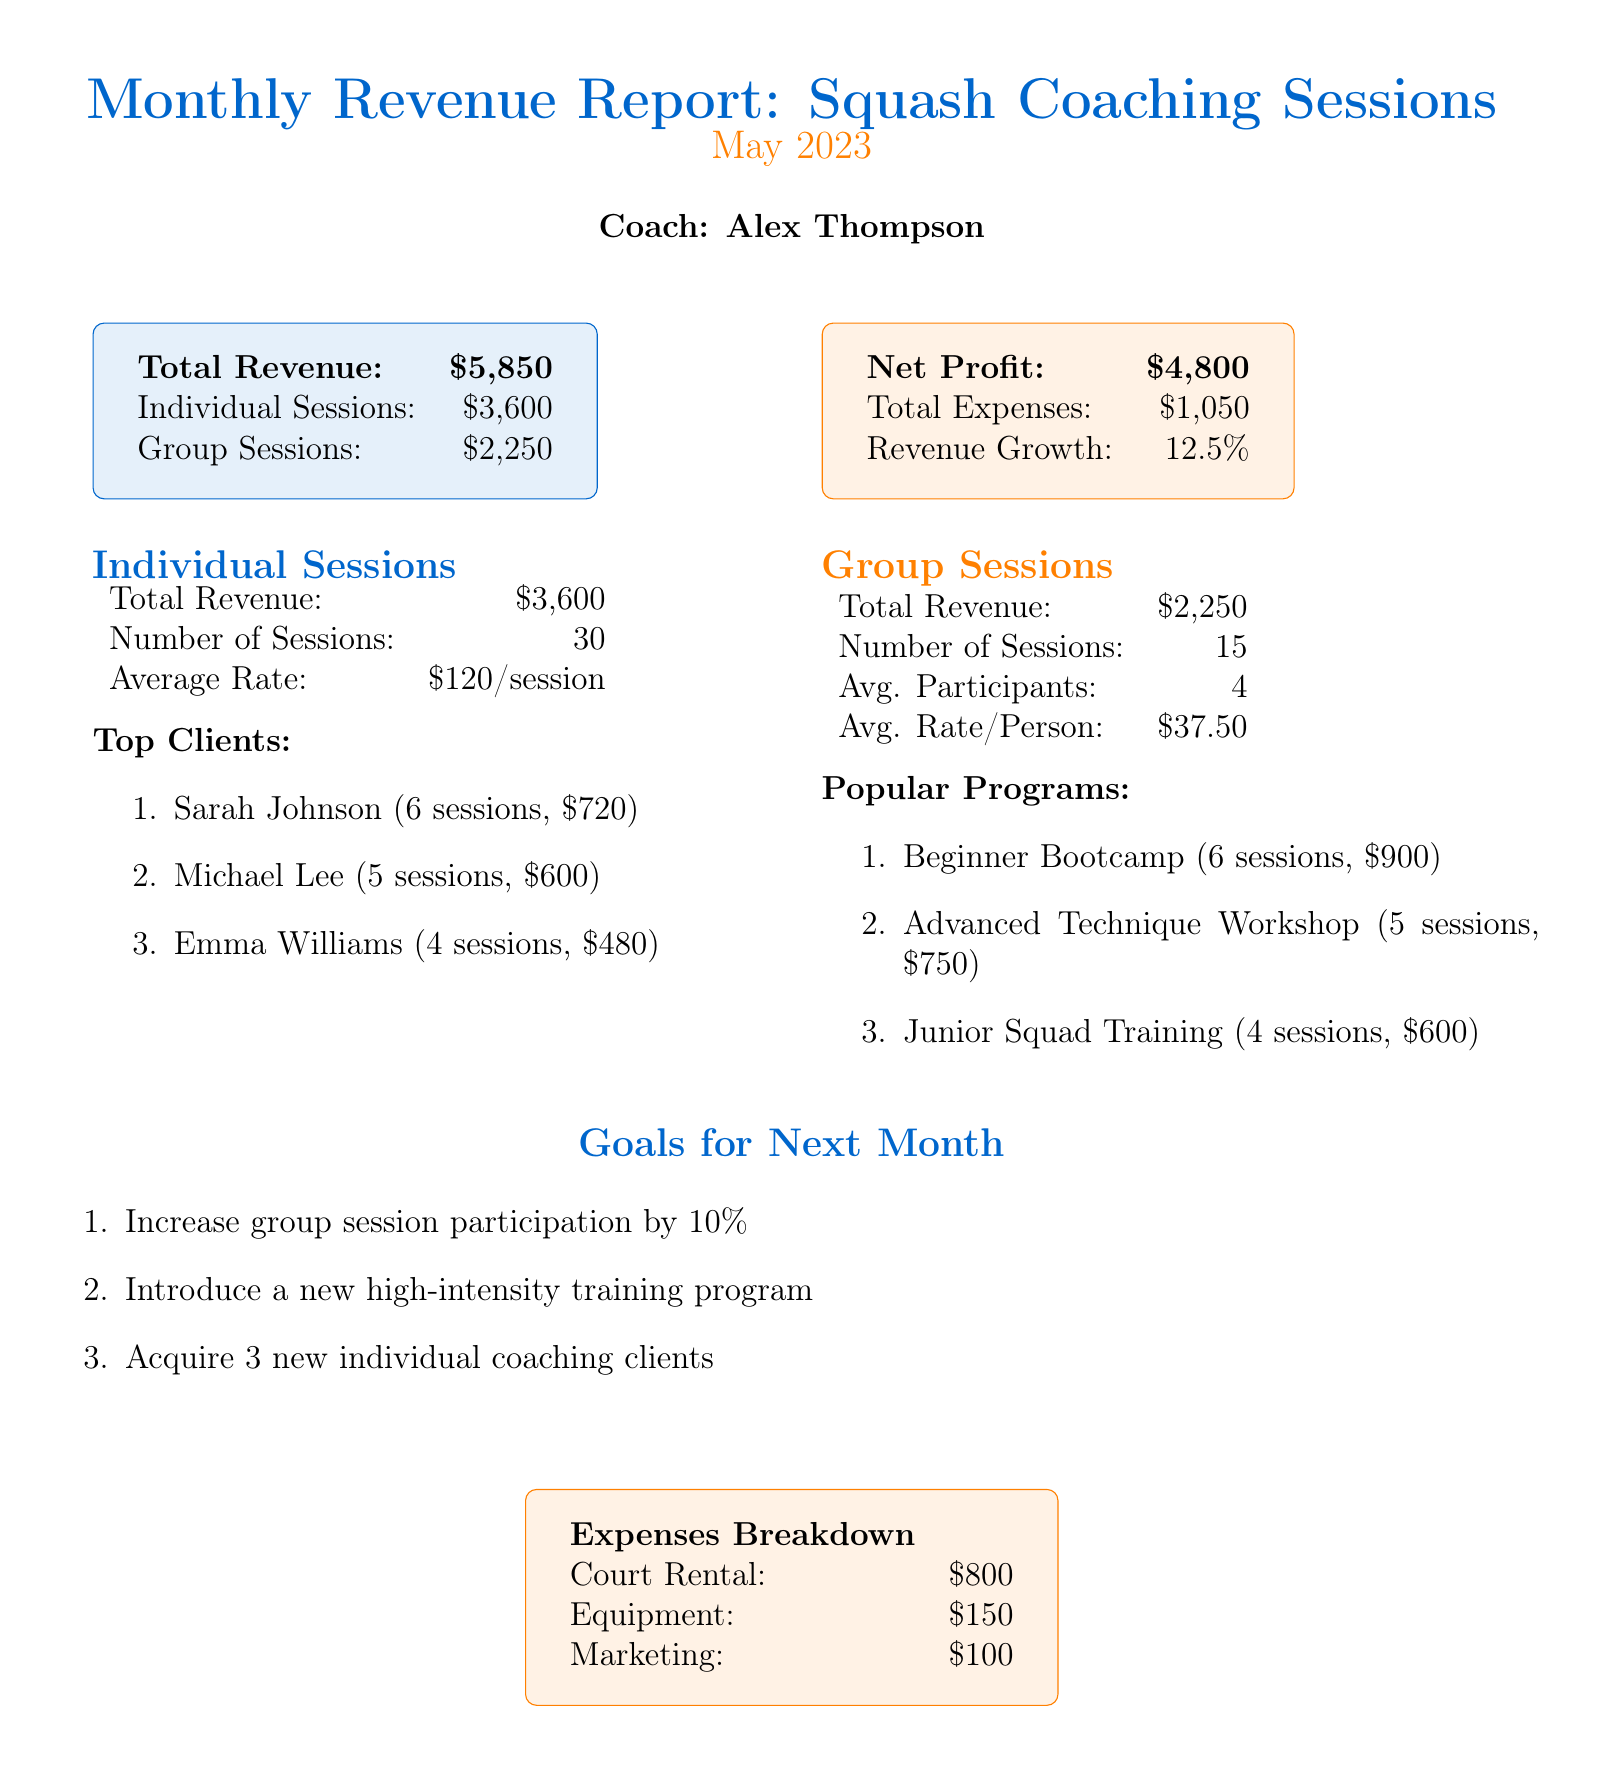what is the total revenue? The total revenue is stated in the document as $5850.
Answer: $5850 how much revenue was generated from individual sessions? The revenue from individual sessions is detailed as $3600 in the document.
Answer: $3600 how many sessions were conducted in total? The total number of sessions is calculated as 30 individual sessions plus 15 group sessions, totaling to 45.
Answer: 45 who is the top client for individual sessions? The document lists Sarah Johnson as the top client for individual sessions with 6 sessions and $720 revenue.
Answer: Sarah Johnson what percentage increase in revenue was achieved compared to the previous month? The document mentions a revenue growth of 12.5% from the previous month.
Answer: 12.5% what is the average rate for group sessions per person? The average rate per person for group sessions is stated as $37.50 in the document.
Answer: $37.50 how many popular programs were listed under group sessions? The document features three popular programs listed under group sessions.
Answer: 3 what is the total amount spent on marketing? The total amount spent on marketing is specified as $100 in the expenses breakdown.
Answer: $100 what goal is set for increasing group session participation? The document states the goal to "Increase group session participation by 10%".
Answer: Increase by 10% 